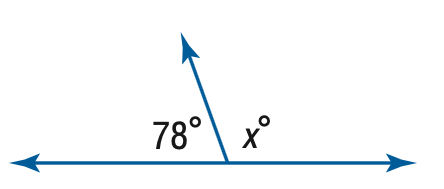Question: Find x.
Choices:
A. 92
B. 102
C. 112
D. 122
Answer with the letter. Answer: B 